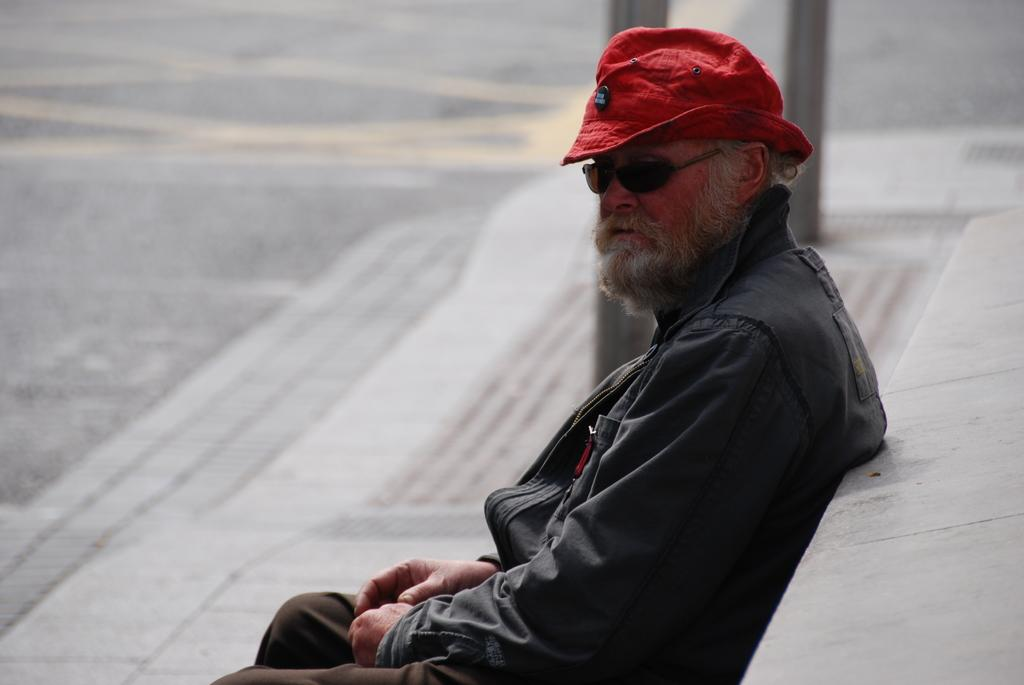What is the main subject of the image? The main subject of the image is a man. What type of clothing is the man wearing? The man is wearing a coat and a cap. What can be seen in the background of the image? There is a road visible at the top of the image. What type of mint is the man chewing in the image? There is no mint present in the image, and the man's actions are not described. What type of lamp is visible in the image? There is no lamp present in the image. 